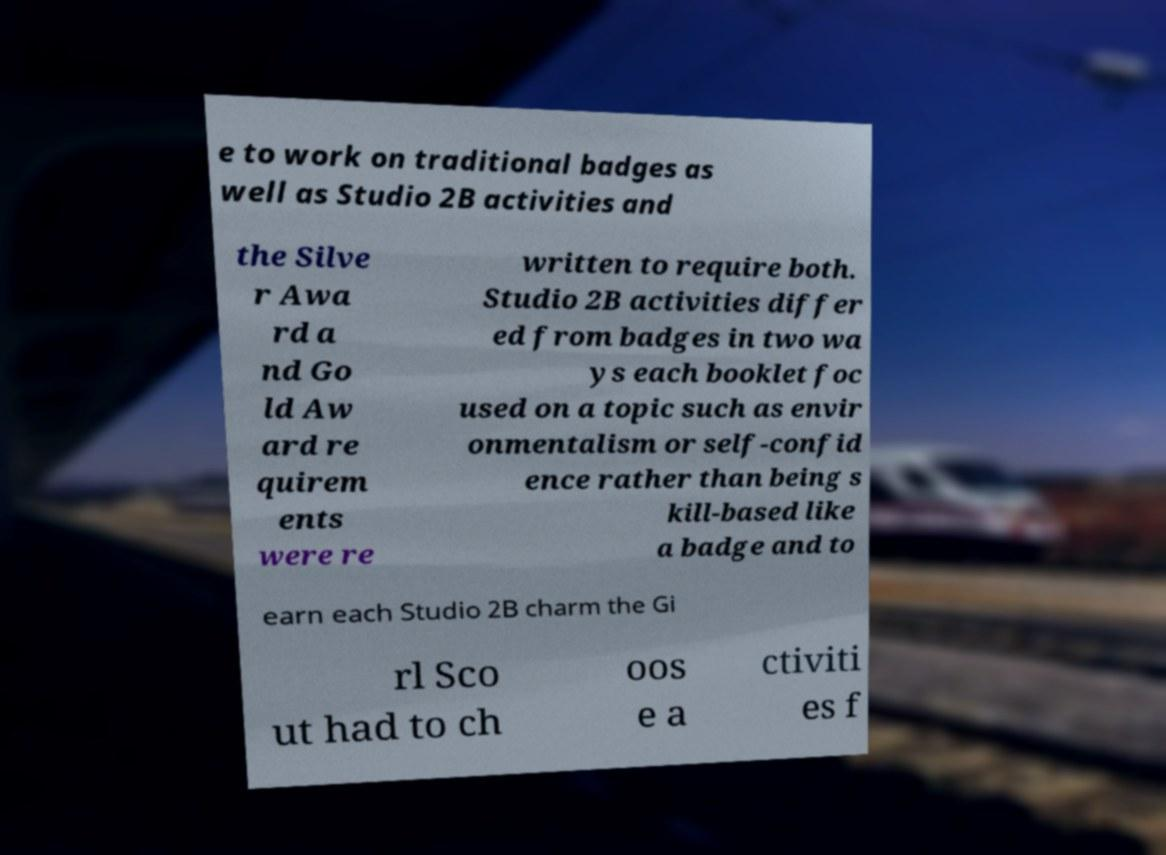For documentation purposes, I need the text within this image transcribed. Could you provide that? e to work on traditional badges as well as Studio 2B activities and the Silve r Awa rd a nd Go ld Aw ard re quirem ents were re written to require both. Studio 2B activities differ ed from badges in two wa ys each booklet foc used on a topic such as envir onmentalism or self-confid ence rather than being s kill-based like a badge and to earn each Studio 2B charm the Gi rl Sco ut had to ch oos e a ctiviti es f 